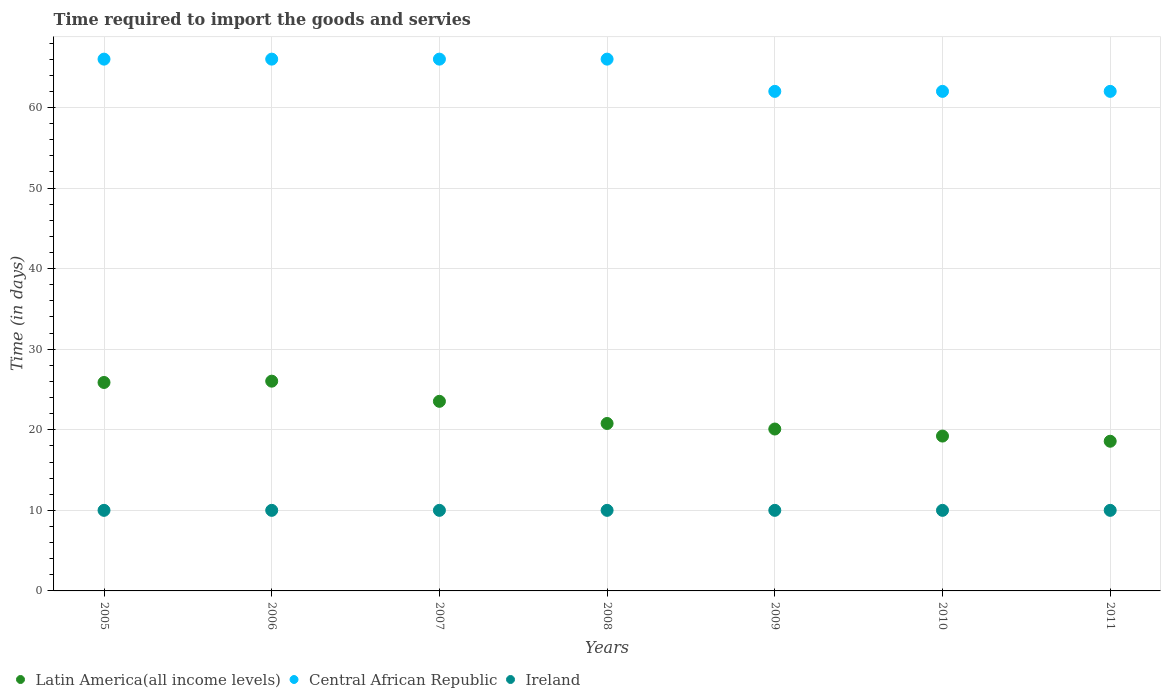How many different coloured dotlines are there?
Offer a very short reply. 3. What is the number of days required to import the goods and services in Ireland in 2010?
Your response must be concise. 10. Across all years, what is the maximum number of days required to import the goods and services in Central African Republic?
Make the answer very short. 66. Across all years, what is the minimum number of days required to import the goods and services in Ireland?
Make the answer very short. 10. What is the total number of days required to import the goods and services in Latin America(all income levels) in the graph?
Make the answer very short. 154.1. What is the difference between the number of days required to import the goods and services in Latin America(all income levels) in 2005 and that in 2010?
Your answer should be compact. 6.65. What is the difference between the number of days required to import the goods and services in Latin America(all income levels) in 2011 and the number of days required to import the goods and services in Central African Republic in 2009?
Your answer should be compact. -43.42. In the year 2008, what is the difference between the number of days required to import the goods and services in Ireland and number of days required to import the goods and services in Central African Republic?
Ensure brevity in your answer.  -56. Is the number of days required to import the goods and services in Ireland in 2006 less than that in 2007?
Offer a terse response. No. What is the difference between the highest and the lowest number of days required to import the goods and services in Central African Republic?
Your answer should be compact. 4. In how many years, is the number of days required to import the goods and services in Ireland greater than the average number of days required to import the goods and services in Ireland taken over all years?
Give a very brief answer. 0. Is the sum of the number of days required to import the goods and services in Ireland in 2005 and 2007 greater than the maximum number of days required to import the goods and services in Central African Republic across all years?
Offer a terse response. No. What is the difference between two consecutive major ticks on the Y-axis?
Your answer should be compact. 10. Where does the legend appear in the graph?
Offer a very short reply. Bottom left. What is the title of the graph?
Your answer should be compact. Time required to import the goods and servies. What is the label or title of the Y-axis?
Provide a succinct answer. Time (in days). What is the Time (in days) of Latin America(all income levels) in 2005?
Ensure brevity in your answer.  25.87. What is the Time (in days) of Central African Republic in 2005?
Keep it short and to the point. 66. What is the Time (in days) in Ireland in 2005?
Offer a terse response. 10. What is the Time (in days) in Latin America(all income levels) in 2006?
Provide a succinct answer. 26.03. What is the Time (in days) of Latin America(all income levels) in 2007?
Keep it short and to the point. 23.53. What is the Time (in days) of Central African Republic in 2007?
Make the answer very short. 66. What is the Time (in days) in Ireland in 2007?
Your answer should be compact. 10. What is the Time (in days) in Latin America(all income levels) in 2008?
Your answer should be compact. 20.78. What is the Time (in days) in Central African Republic in 2008?
Offer a terse response. 66. What is the Time (in days) in Ireland in 2008?
Give a very brief answer. 10. What is the Time (in days) in Latin America(all income levels) in 2009?
Provide a succinct answer. 20.09. What is the Time (in days) of Central African Republic in 2009?
Provide a short and direct response. 62. What is the Time (in days) in Latin America(all income levels) in 2010?
Your answer should be very brief. 19.22. What is the Time (in days) of Latin America(all income levels) in 2011?
Make the answer very short. 18.58. What is the Time (in days) of Ireland in 2011?
Your response must be concise. 10. Across all years, what is the maximum Time (in days) of Latin America(all income levels)?
Keep it short and to the point. 26.03. Across all years, what is the maximum Time (in days) in Ireland?
Keep it short and to the point. 10. Across all years, what is the minimum Time (in days) of Latin America(all income levels)?
Offer a terse response. 18.58. Across all years, what is the minimum Time (in days) in Ireland?
Your response must be concise. 10. What is the total Time (in days) of Latin America(all income levels) in the graph?
Provide a succinct answer. 154.1. What is the total Time (in days) of Central African Republic in the graph?
Make the answer very short. 450. What is the total Time (in days) in Ireland in the graph?
Make the answer very short. 70. What is the difference between the Time (in days) in Latin America(all income levels) in 2005 and that in 2006?
Your response must be concise. -0.16. What is the difference between the Time (in days) of Central African Republic in 2005 and that in 2006?
Offer a very short reply. 0. What is the difference between the Time (in days) of Ireland in 2005 and that in 2006?
Offer a terse response. 0. What is the difference between the Time (in days) in Latin America(all income levels) in 2005 and that in 2007?
Your answer should be very brief. 2.34. What is the difference between the Time (in days) of Central African Republic in 2005 and that in 2007?
Provide a succinct answer. 0. What is the difference between the Time (in days) of Latin America(all income levels) in 2005 and that in 2008?
Your answer should be compact. 5.09. What is the difference between the Time (in days) in Central African Republic in 2005 and that in 2008?
Ensure brevity in your answer.  0. What is the difference between the Time (in days) in Ireland in 2005 and that in 2008?
Your response must be concise. 0. What is the difference between the Time (in days) of Latin America(all income levels) in 2005 and that in 2009?
Provide a short and direct response. 5.78. What is the difference between the Time (in days) in Latin America(all income levels) in 2005 and that in 2010?
Make the answer very short. 6.65. What is the difference between the Time (in days) of Central African Republic in 2005 and that in 2010?
Your answer should be very brief. 4. What is the difference between the Time (in days) of Latin America(all income levels) in 2005 and that in 2011?
Your response must be concise. 7.3. What is the difference between the Time (in days) in Latin America(all income levels) in 2006 and that in 2007?
Ensure brevity in your answer.  2.5. What is the difference between the Time (in days) of Ireland in 2006 and that in 2007?
Your answer should be very brief. 0. What is the difference between the Time (in days) of Latin America(all income levels) in 2006 and that in 2008?
Provide a short and direct response. 5.25. What is the difference between the Time (in days) of Central African Republic in 2006 and that in 2008?
Give a very brief answer. 0. What is the difference between the Time (in days) in Latin America(all income levels) in 2006 and that in 2009?
Your answer should be compact. 5.94. What is the difference between the Time (in days) of Central African Republic in 2006 and that in 2009?
Keep it short and to the point. 4. What is the difference between the Time (in days) of Latin America(all income levels) in 2006 and that in 2010?
Your answer should be very brief. 6.81. What is the difference between the Time (in days) in Latin America(all income levels) in 2006 and that in 2011?
Ensure brevity in your answer.  7.46. What is the difference between the Time (in days) of Latin America(all income levels) in 2007 and that in 2008?
Offer a very short reply. 2.75. What is the difference between the Time (in days) of Latin America(all income levels) in 2007 and that in 2009?
Make the answer very short. 3.44. What is the difference between the Time (in days) of Ireland in 2007 and that in 2009?
Give a very brief answer. 0. What is the difference between the Time (in days) in Latin America(all income levels) in 2007 and that in 2010?
Provide a succinct answer. 4.31. What is the difference between the Time (in days) of Ireland in 2007 and that in 2010?
Your answer should be very brief. 0. What is the difference between the Time (in days) in Latin America(all income levels) in 2007 and that in 2011?
Offer a very short reply. 4.96. What is the difference between the Time (in days) in Central African Republic in 2007 and that in 2011?
Your answer should be compact. 4. What is the difference between the Time (in days) in Ireland in 2007 and that in 2011?
Provide a succinct answer. 0. What is the difference between the Time (in days) in Latin America(all income levels) in 2008 and that in 2009?
Provide a short and direct response. 0.69. What is the difference between the Time (in days) of Latin America(all income levels) in 2008 and that in 2010?
Offer a very short reply. 1.56. What is the difference between the Time (in days) of Central African Republic in 2008 and that in 2010?
Your response must be concise. 4. What is the difference between the Time (in days) in Latin America(all income levels) in 2008 and that in 2011?
Provide a short and direct response. 2.21. What is the difference between the Time (in days) of Ireland in 2008 and that in 2011?
Your answer should be very brief. 0. What is the difference between the Time (in days) of Latin America(all income levels) in 2009 and that in 2010?
Your answer should be compact. 0.88. What is the difference between the Time (in days) in Latin America(all income levels) in 2009 and that in 2011?
Provide a succinct answer. 1.52. What is the difference between the Time (in days) of Ireland in 2009 and that in 2011?
Give a very brief answer. 0. What is the difference between the Time (in days) in Latin America(all income levels) in 2010 and that in 2011?
Make the answer very short. 0.64. What is the difference between the Time (in days) in Ireland in 2010 and that in 2011?
Your response must be concise. 0. What is the difference between the Time (in days) of Latin America(all income levels) in 2005 and the Time (in days) of Central African Republic in 2006?
Your answer should be compact. -40.13. What is the difference between the Time (in days) in Latin America(all income levels) in 2005 and the Time (in days) in Ireland in 2006?
Provide a succinct answer. 15.87. What is the difference between the Time (in days) of Latin America(all income levels) in 2005 and the Time (in days) of Central African Republic in 2007?
Ensure brevity in your answer.  -40.13. What is the difference between the Time (in days) in Latin America(all income levels) in 2005 and the Time (in days) in Ireland in 2007?
Your response must be concise. 15.87. What is the difference between the Time (in days) of Latin America(all income levels) in 2005 and the Time (in days) of Central African Republic in 2008?
Provide a succinct answer. -40.13. What is the difference between the Time (in days) in Latin America(all income levels) in 2005 and the Time (in days) in Ireland in 2008?
Ensure brevity in your answer.  15.87. What is the difference between the Time (in days) of Central African Republic in 2005 and the Time (in days) of Ireland in 2008?
Offer a terse response. 56. What is the difference between the Time (in days) in Latin America(all income levels) in 2005 and the Time (in days) in Central African Republic in 2009?
Keep it short and to the point. -36.13. What is the difference between the Time (in days) of Latin America(all income levels) in 2005 and the Time (in days) of Ireland in 2009?
Make the answer very short. 15.87. What is the difference between the Time (in days) in Latin America(all income levels) in 2005 and the Time (in days) in Central African Republic in 2010?
Offer a very short reply. -36.13. What is the difference between the Time (in days) in Latin America(all income levels) in 2005 and the Time (in days) in Ireland in 2010?
Ensure brevity in your answer.  15.87. What is the difference between the Time (in days) of Latin America(all income levels) in 2005 and the Time (in days) of Central African Republic in 2011?
Offer a very short reply. -36.13. What is the difference between the Time (in days) in Latin America(all income levels) in 2005 and the Time (in days) in Ireland in 2011?
Offer a terse response. 15.87. What is the difference between the Time (in days) in Central African Republic in 2005 and the Time (in days) in Ireland in 2011?
Make the answer very short. 56. What is the difference between the Time (in days) in Latin America(all income levels) in 2006 and the Time (in days) in Central African Republic in 2007?
Your answer should be very brief. -39.97. What is the difference between the Time (in days) of Latin America(all income levels) in 2006 and the Time (in days) of Ireland in 2007?
Give a very brief answer. 16.03. What is the difference between the Time (in days) of Central African Republic in 2006 and the Time (in days) of Ireland in 2007?
Provide a succinct answer. 56. What is the difference between the Time (in days) of Latin America(all income levels) in 2006 and the Time (in days) of Central African Republic in 2008?
Keep it short and to the point. -39.97. What is the difference between the Time (in days) of Latin America(all income levels) in 2006 and the Time (in days) of Ireland in 2008?
Make the answer very short. 16.03. What is the difference between the Time (in days) in Central African Republic in 2006 and the Time (in days) in Ireland in 2008?
Provide a short and direct response. 56. What is the difference between the Time (in days) of Latin America(all income levels) in 2006 and the Time (in days) of Central African Republic in 2009?
Make the answer very short. -35.97. What is the difference between the Time (in days) of Latin America(all income levels) in 2006 and the Time (in days) of Ireland in 2009?
Provide a short and direct response. 16.03. What is the difference between the Time (in days) of Latin America(all income levels) in 2006 and the Time (in days) of Central African Republic in 2010?
Offer a very short reply. -35.97. What is the difference between the Time (in days) in Latin America(all income levels) in 2006 and the Time (in days) in Ireland in 2010?
Your response must be concise. 16.03. What is the difference between the Time (in days) in Central African Republic in 2006 and the Time (in days) in Ireland in 2010?
Your response must be concise. 56. What is the difference between the Time (in days) in Latin America(all income levels) in 2006 and the Time (in days) in Central African Republic in 2011?
Keep it short and to the point. -35.97. What is the difference between the Time (in days) of Latin America(all income levels) in 2006 and the Time (in days) of Ireland in 2011?
Offer a terse response. 16.03. What is the difference between the Time (in days) of Central African Republic in 2006 and the Time (in days) of Ireland in 2011?
Give a very brief answer. 56. What is the difference between the Time (in days) of Latin America(all income levels) in 2007 and the Time (in days) of Central African Republic in 2008?
Provide a succinct answer. -42.47. What is the difference between the Time (in days) in Latin America(all income levels) in 2007 and the Time (in days) in Ireland in 2008?
Provide a short and direct response. 13.53. What is the difference between the Time (in days) in Latin America(all income levels) in 2007 and the Time (in days) in Central African Republic in 2009?
Give a very brief answer. -38.47. What is the difference between the Time (in days) in Latin America(all income levels) in 2007 and the Time (in days) in Ireland in 2009?
Offer a terse response. 13.53. What is the difference between the Time (in days) of Latin America(all income levels) in 2007 and the Time (in days) of Central African Republic in 2010?
Provide a succinct answer. -38.47. What is the difference between the Time (in days) of Latin America(all income levels) in 2007 and the Time (in days) of Ireland in 2010?
Ensure brevity in your answer.  13.53. What is the difference between the Time (in days) of Latin America(all income levels) in 2007 and the Time (in days) of Central African Republic in 2011?
Your answer should be very brief. -38.47. What is the difference between the Time (in days) in Latin America(all income levels) in 2007 and the Time (in days) in Ireland in 2011?
Provide a short and direct response. 13.53. What is the difference between the Time (in days) of Latin America(all income levels) in 2008 and the Time (in days) of Central African Republic in 2009?
Give a very brief answer. -41.22. What is the difference between the Time (in days) in Latin America(all income levels) in 2008 and the Time (in days) in Ireland in 2009?
Ensure brevity in your answer.  10.78. What is the difference between the Time (in days) of Central African Republic in 2008 and the Time (in days) of Ireland in 2009?
Your answer should be compact. 56. What is the difference between the Time (in days) in Latin America(all income levels) in 2008 and the Time (in days) in Central African Republic in 2010?
Ensure brevity in your answer.  -41.22. What is the difference between the Time (in days) of Latin America(all income levels) in 2008 and the Time (in days) of Ireland in 2010?
Provide a short and direct response. 10.78. What is the difference between the Time (in days) of Central African Republic in 2008 and the Time (in days) of Ireland in 2010?
Keep it short and to the point. 56. What is the difference between the Time (in days) of Latin America(all income levels) in 2008 and the Time (in days) of Central African Republic in 2011?
Your answer should be compact. -41.22. What is the difference between the Time (in days) in Latin America(all income levels) in 2008 and the Time (in days) in Ireland in 2011?
Your answer should be compact. 10.78. What is the difference between the Time (in days) in Latin America(all income levels) in 2009 and the Time (in days) in Central African Republic in 2010?
Provide a short and direct response. -41.91. What is the difference between the Time (in days) in Latin America(all income levels) in 2009 and the Time (in days) in Ireland in 2010?
Ensure brevity in your answer.  10.09. What is the difference between the Time (in days) of Latin America(all income levels) in 2009 and the Time (in days) of Central African Republic in 2011?
Keep it short and to the point. -41.91. What is the difference between the Time (in days) of Latin America(all income levels) in 2009 and the Time (in days) of Ireland in 2011?
Make the answer very short. 10.09. What is the difference between the Time (in days) of Latin America(all income levels) in 2010 and the Time (in days) of Central African Republic in 2011?
Offer a very short reply. -42.78. What is the difference between the Time (in days) of Latin America(all income levels) in 2010 and the Time (in days) of Ireland in 2011?
Keep it short and to the point. 9.22. What is the average Time (in days) in Latin America(all income levels) per year?
Your answer should be very brief. 22.01. What is the average Time (in days) of Central African Republic per year?
Keep it short and to the point. 64.29. What is the average Time (in days) of Ireland per year?
Make the answer very short. 10. In the year 2005, what is the difference between the Time (in days) in Latin America(all income levels) and Time (in days) in Central African Republic?
Offer a terse response. -40.13. In the year 2005, what is the difference between the Time (in days) of Latin America(all income levels) and Time (in days) of Ireland?
Provide a short and direct response. 15.87. In the year 2006, what is the difference between the Time (in days) in Latin America(all income levels) and Time (in days) in Central African Republic?
Ensure brevity in your answer.  -39.97. In the year 2006, what is the difference between the Time (in days) of Latin America(all income levels) and Time (in days) of Ireland?
Your response must be concise. 16.03. In the year 2007, what is the difference between the Time (in days) of Latin America(all income levels) and Time (in days) of Central African Republic?
Keep it short and to the point. -42.47. In the year 2007, what is the difference between the Time (in days) of Latin America(all income levels) and Time (in days) of Ireland?
Provide a succinct answer. 13.53. In the year 2007, what is the difference between the Time (in days) of Central African Republic and Time (in days) of Ireland?
Ensure brevity in your answer.  56. In the year 2008, what is the difference between the Time (in days) of Latin America(all income levels) and Time (in days) of Central African Republic?
Keep it short and to the point. -45.22. In the year 2008, what is the difference between the Time (in days) in Latin America(all income levels) and Time (in days) in Ireland?
Provide a short and direct response. 10.78. In the year 2009, what is the difference between the Time (in days) in Latin America(all income levels) and Time (in days) in Central African Republic?
Provide a succinct answer. -41.91. In the year 2009, what is the difference between the Time (in days) of Latin America(all income levels) and Time (in days) of Ireland?
Provide a succinct answer. 10.09. In the year 2010, what is the difference between the Time (in days) of Latin America(all income levels) and Time (in days) of Central African Republic?
Your response must be concise. -42.78. In the year 2010, what is the difference between the Time (in days) in Latin America(all income levels) and Time (in days) in Ireland?
Your response must be concise. 9.22. In the year 2011, what is the difference between the Time (in days) in Latin America(all income levels) and Time (in days) in Central African Republic?
Make the answer very short. -43.42. In the year 2011, what is the difference between the Time (in days) in Latin America(all income levels) and Time (in days) in Ireland?
Provide a short and direct response. 8.58. What is the ratio of the Time (in days) of Latin America(all income levels) in 2005 to that in 2006?
Offer a terse response. 0.99. What is the ratio of the Time (in days) in Central African Republic in 2005 to that in 2006?
Ensure brevity in your answer.  1. What is the ratio of the Time (in days) in Latin America(all income levels) in 2005 to that in 2007?
Make the answer very short. 1.1. What is the ratio of the Time (in days) of Central African Republic in 2005 to that in 2007?
Keep it short and to the point. 1. What is the ratio of the Time (in days) in Latin America(all income levels) in 2005 to that in 2008?
Your response must be concise. 1.24. What is the ratio of the Time (in days) of Ireland in 2005 to that in 2008?
Your answer should be compact. 1. What is the ratio of the Time (in days) in Latin America(all income levels) in 2005 to that in 2009?
Your response must be concise. 1.29. What is the ratio of the Time (in days) of Central African Republic in 2005 to that in 2009?
Give a very brief answer. 1.06. What is the ratio of the Time (in days) in Latin America(all income levels) in 2005 to that in 2010?
Your response must be concise. 1.35. What is the ratio of the Time (in days) of Central African Republic in 2005 to that in 2010?
Provide a short and direct response. 1.06. What is the ratio of the Time (in days) in Latin America(all income levels) in 2005 to that in 2011?
Your answer should be very brief. 1.39. What is the ratio of the Time (in days) in Central African Republic in 2005 to that in 2011?
Your response must be concise. 1.06. What is the ratio of the Time (in days) of Latin America(all income levels) in 2006 to that in 2007?
Provide a short and direct response. 1.11. What is the ratio of the Time (in days) in Central African Republic in 2006 to that in 2007?
Your answer should be compact. 1. What is the ratio of the Time (in days) in Ireland in 2006 to that in 2007?
Your answer should be compact. 1. What is the ratio of the Time (in days) in Latin America(all income levels) in 2006 to that in 2008?
Your answer should be compact. 1.25. What is the ratio of the Time (in days) in Central African Republic in 2006 to that in 2008?
Provide a succinct answer. 1. What is the ratio of the Time (in days) in Ireland in 2006 to that in 2008?
Give a very brief answer. 1. What is the ratio of the Time (in days) in Latin America(all income levels) in 2006 to that in 2009?
Make the answer very short. 1.3. What is the ratio of the Time (in days) in Central African Republic in 2006 to that in 2009?
Your answer should be compact. 1.06. What is the ratio of the Time (in days) of Latin America(all income levels) in 2006 to that in 2010?
Ensure brevity in your answer.  1.35. What is the ratio of the Time (in days) of Central African Republic in 2006 to that in 2010?
Your response must be concise. 1.06. What is the ratio of the Time (in days) of Ireland in 2006 to that in 2010?
Your answer should be very brief. 1. What is the ratio of the Time (in days) of Latin America(all income levels) in 2006 to that in 2011?
Provide a succinct answer. 1.4. What is the ratio of the Time (in days) in Central African Republic in 2006 to that in 2011?
Keep it short and to the point. 1.06. What is the ratio of the Time (in days) of Ireland in 2006 to that in 2011?
Provide a short and direct response. 1. What is the ratio of the Time (in days) in Latin America(all income levels) in 2007 to that in 2008?
Make the answer very short. 1.13. What is the ratio of the Time (in days) in Central African Republic in 2007 to that in 2008?
Make the answer very short. 1. What is the ratio of the Time (in days) of Latin America(all income levels) in 2007 to that in 2009?
Offer a very short reply. 1.17. What is the ratio of the Time (in days) in Central African Republic in 2007 to that in 2009?
Your answer should be compact. 1.06. What is the ratio of the Time (in days) of Ireland in 2007 to that in 2009?
Ensure brevity in your answer.  1. What is the ratio of the Time (in days) in Latin America(all income levels) in 2007 to that in 2010?
Give a very brief answer. 1.22. What is the ratio of the Time (in days) of Central African Republic in 2007 to that in 2010?
Offer a terse response. 1.06. What is the ratio of the Time (in days) in Ireland in 2007 to that in 2010?
Provide a succinct answer. 1. What is the ratio of the Time (in days) in Latin America(all income levels) in 2007 to that in 2011?
Provide a succinct answer. 1.27. What is the ratio of the Time (in days) in Central African Republic in 2007 to that in 2011?
Your response must be concise. 1.06. What is the ratio of the Time (in days) in Ireland in 2007 to that in 2011?
Offer a very short reply. 1. What is the ratio of the Time (in days) of Latin America(all income levels) in 2008 to that in 2009?
Offer a very short reply. 1.03. What is the ratio of the Time (in days) in Central African Republic in 2008 to that in 2009?
Provide a succinct answer. 1.06. What is the ratio of the Time (in days) of Ireland in 2008 to that in 2009?
Provide a succinct answer. 1. What is the ratio of the Time (in days) of Latin America(all income levels) in 2008 to that in 2010?
Ensure brevity in your answer.  1.08. What is the ratio of the Time (in days) of Central African Republic in 2008 to that in 2010?
Make the answer very short. 1.06. What is the ratio of the Time (in days) in Latin America(all income levels) in 2008 to that in 2011?
Provide a succinct answer. 1.12. What is the ratio of the Time (in days) of Central African Republic in 2008 to that in 2011?
Offer a very short reply. 1.06. What is the ratio of the Time (in days) of Latin America(all income levels) in 2009 to that in 2010?
Give a very brief answer. 1.05. What is the ratio of the Time (in days) in Central African Republic in 2009 to that in 2010?
Make the answer very short. 1. What is the ratio of the Time (in days) in Latin America(all income levels) in 2009 to that in 2011?
Make the answer very short. 1.08. What is the ratio of the Time (in days) in Ireland in 2009 to that in 2011?
Offer a very short reply. 1. What is the ratio of the Time (in days) of Latin America(all income levels) in 2010 to that in 2011?
Ensure brevity in your answer.  1.03. What is the ratio of the Time (in days) in Central African Republic in 2010 to that in 2011?
Offer a very short reply. 1. What is the ratio of the Time (in days) of Ireland in 2010 to that in 2011?
Your response must be concise. 1. What is the difference between the highest and the second highest Time (in days) of Latin America(all income levels)?
Keep it short and to the point. 0.16. What is the difference between the highest and the second highest Time (in days) in Ireland?
Provide a succinct answer. 0. What is the difference between the highest and the lowest Time (in days) of Latin America(all income levels)?
Provide a succinct answer. 7.46. What is the difference between the highest and the lowest Time (in days) in Central African Republic?
Keep it short and to the point. 4. What is the difference between the highest and the lowest Time (in days) of Ireland?
Your answer should be very brief. 0. 